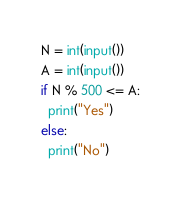<code> <loc_0><loc_0><loc_500><loc_500><_Python_>N = int(input())
A = int(input())
if N % 500 <= A:
  print("Yes")
else:
  print("No")</code> 